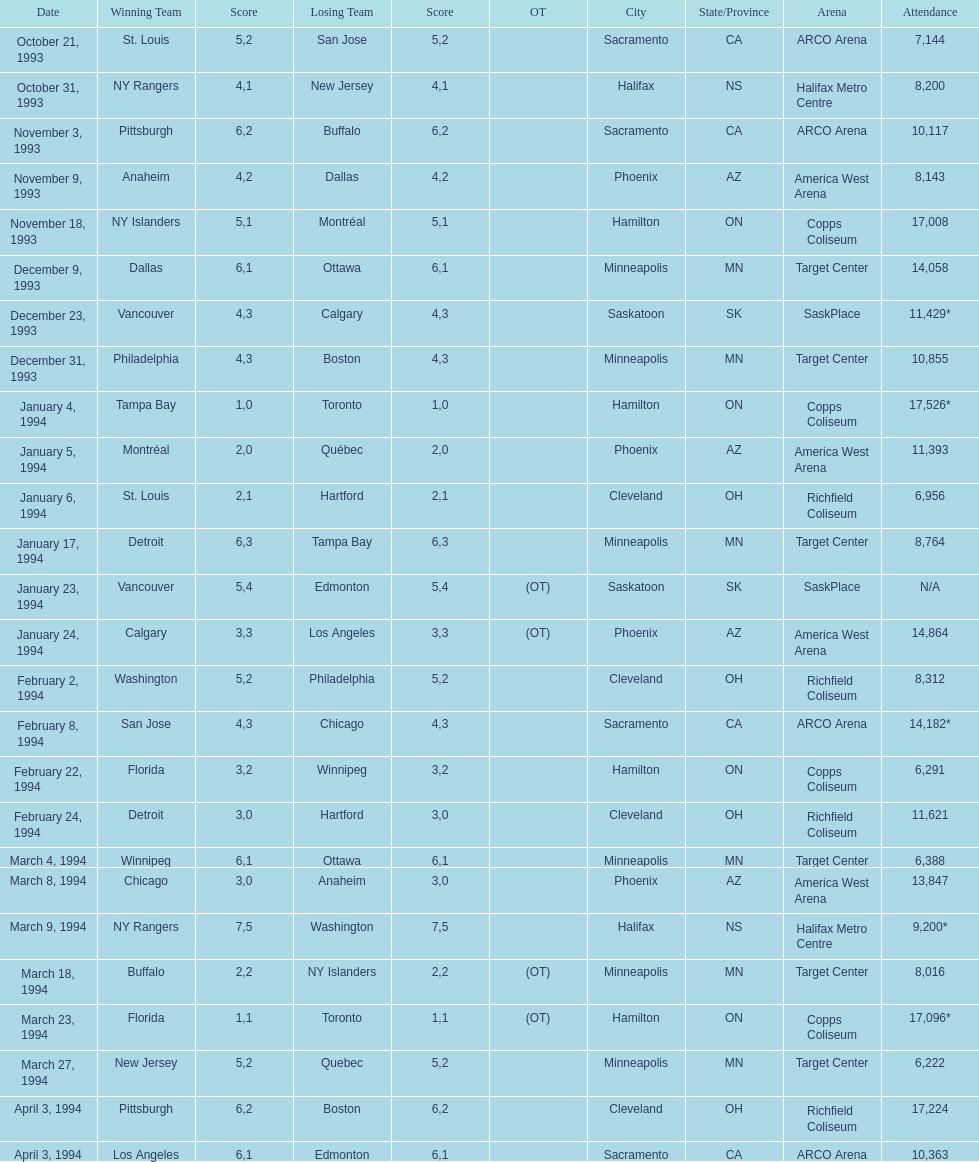How many neutral location games concluded in overtime (ot)? 4. 